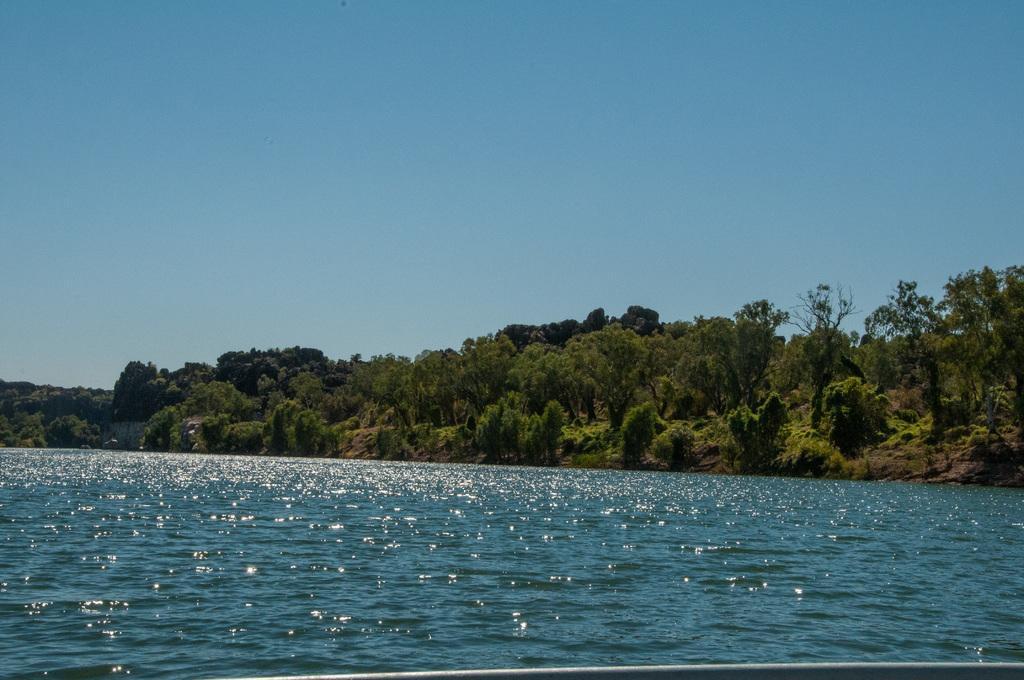Could you give a brief overview of what you see in this image? In this image we can see sky, trees, hills and lake. 